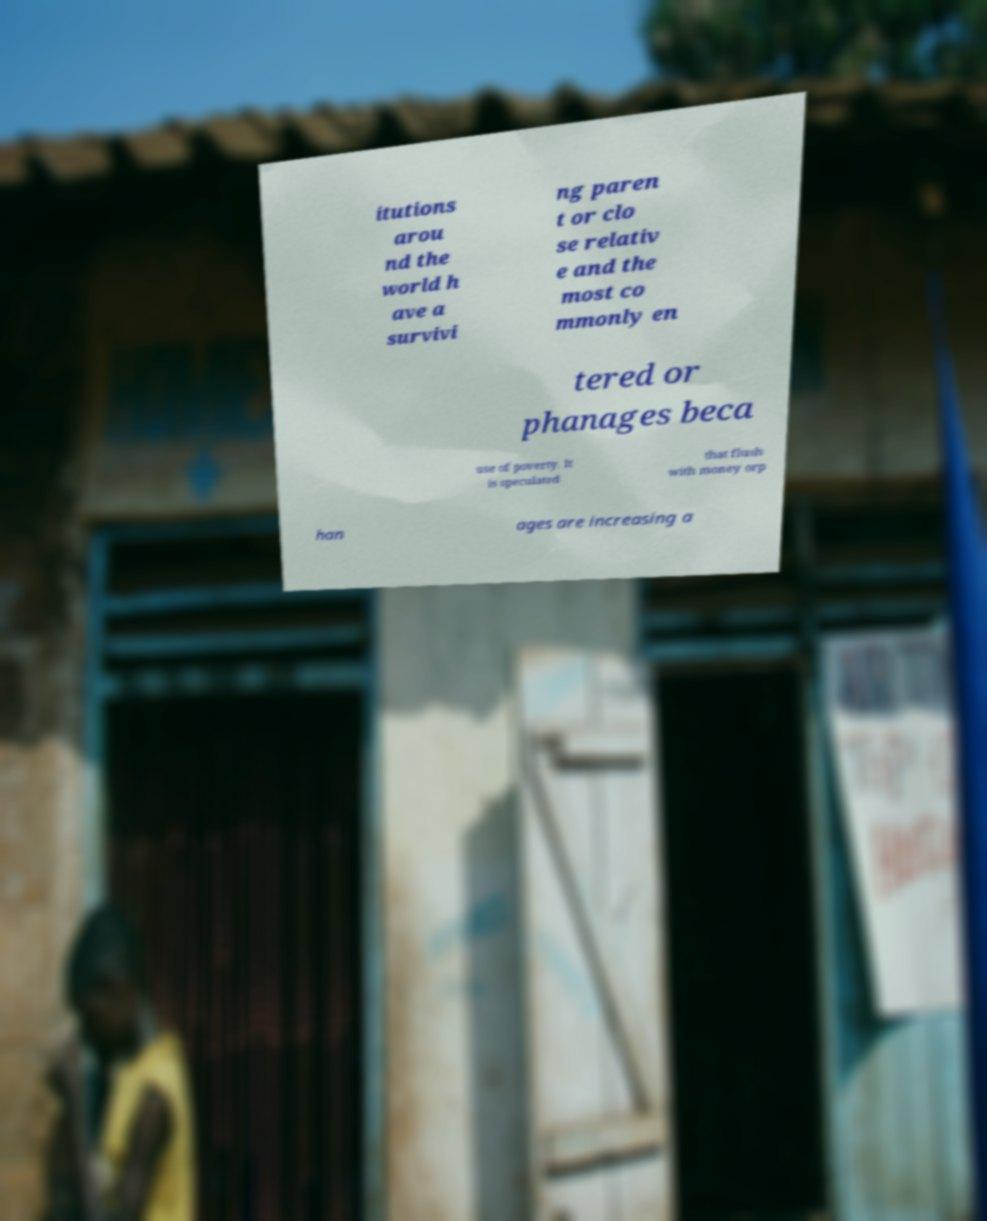Could you extract and type out the text from this image? itutions arou nd the world h ave a survivi ng paren t or clo se relativ e and the most co mmonly en tered or phanages beca use of poverty. It is speculated that flush with money orp han ages are increasing a 